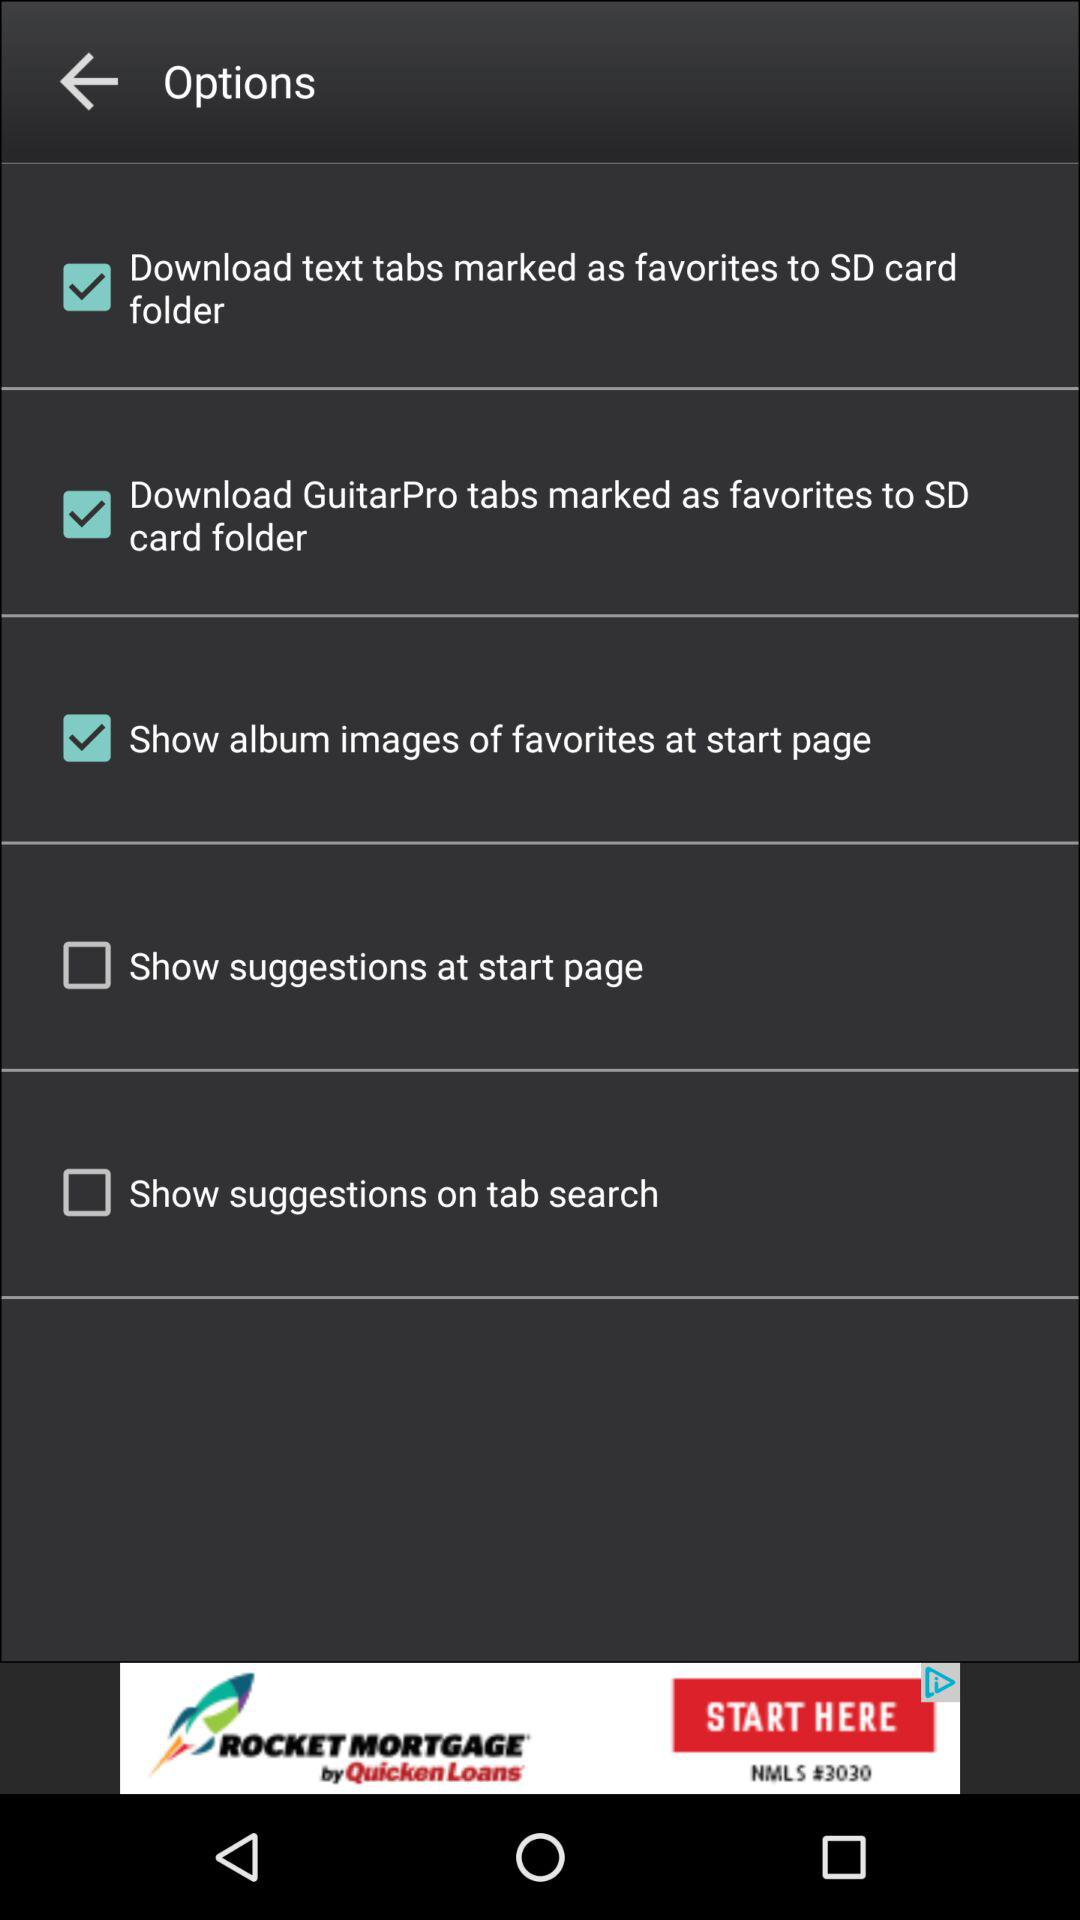What is the status of "Show suggestions at start page"? The status of "Show suggestions at start page" is off. 